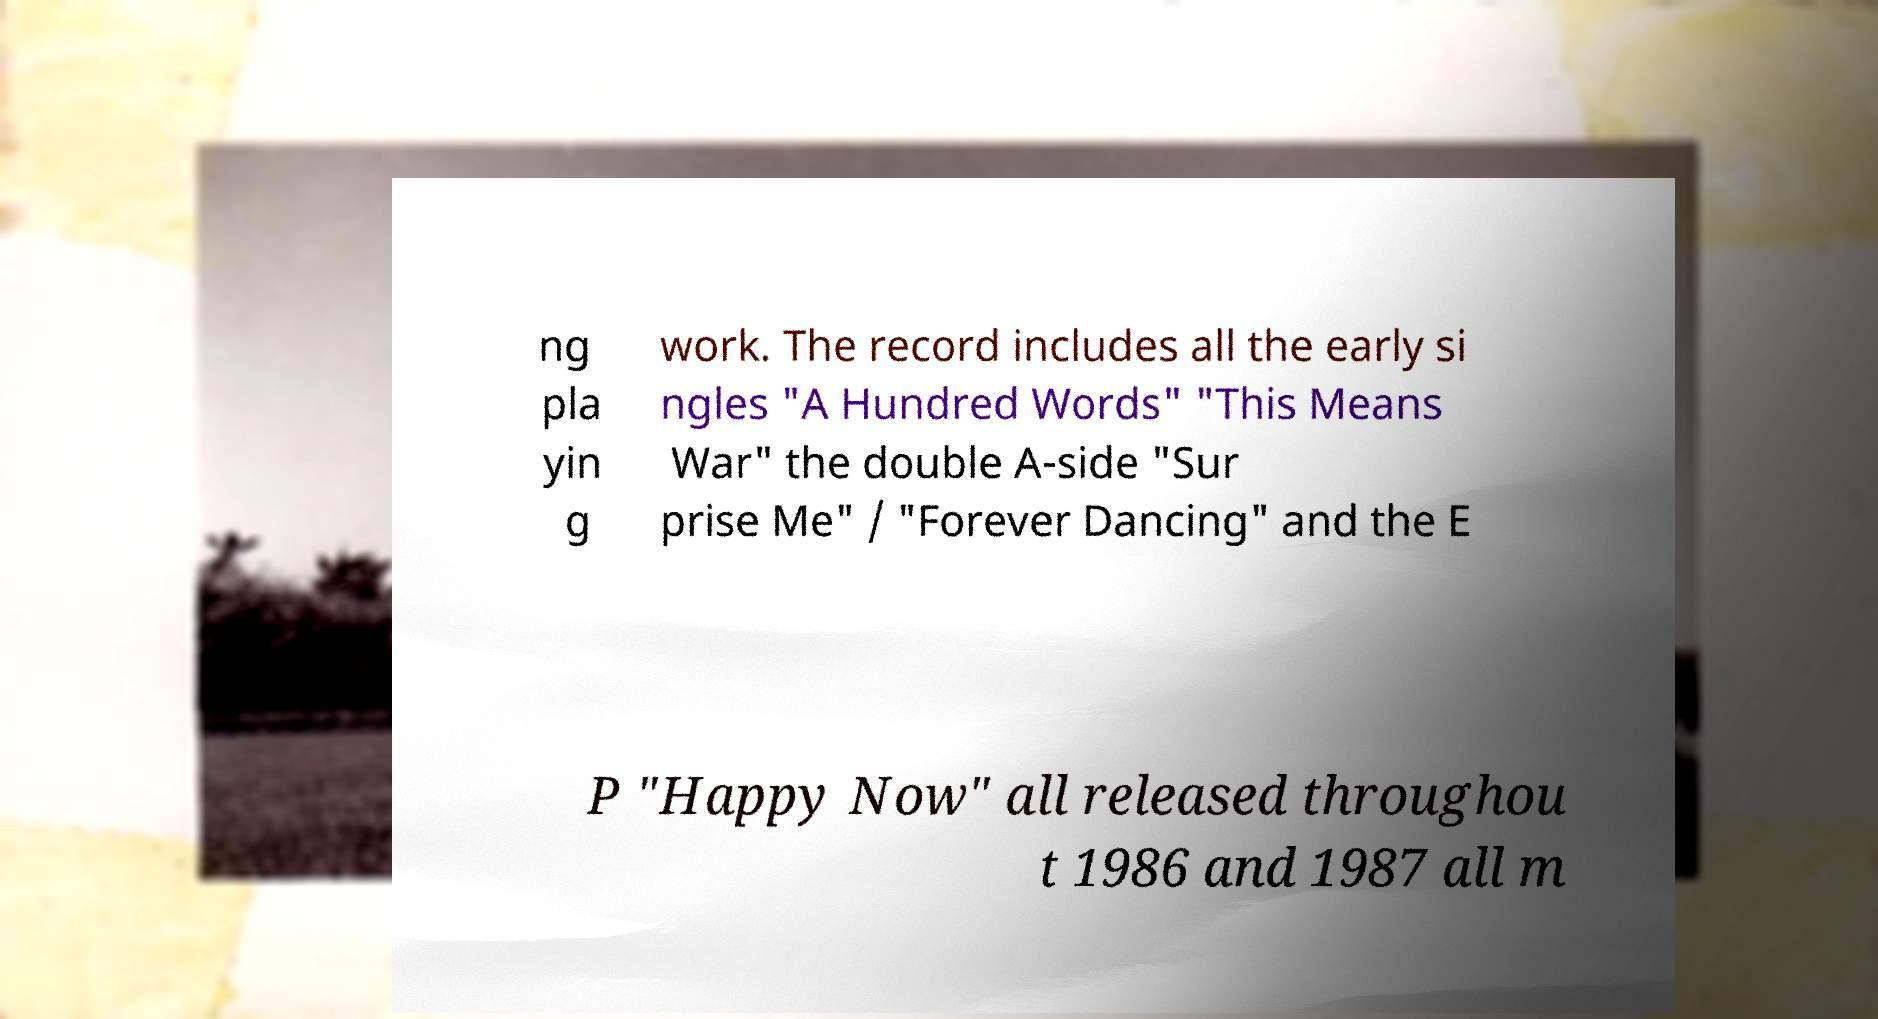Can you read and provide the text displayed in the image?This photo seems to have some interesting text. Can you extract and type it out for me? ng pla yin g work. The record includes all the early si ngles "A Hundred Words" "This Means War" the double A-side "Sur prise Me" / "Forever Dancing" and the E P "Happy Now" all released throughou t 1986 and 1987 all m 